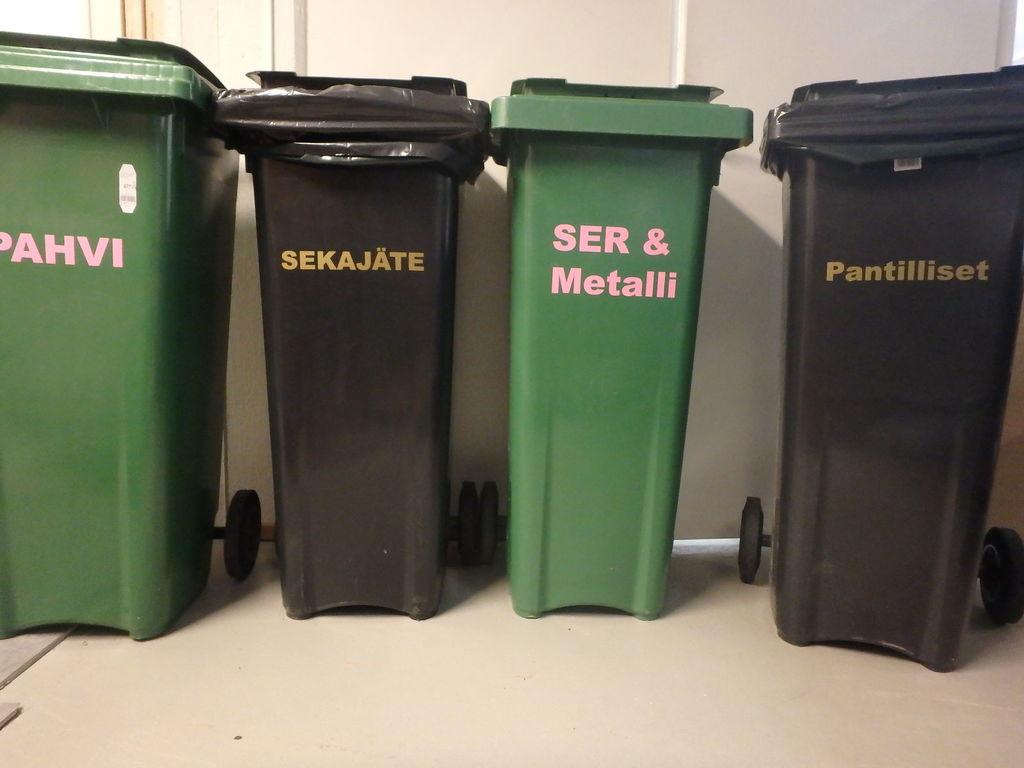What is on the right trash can?
Ensure brevity in your answer.  Pantilliset. 